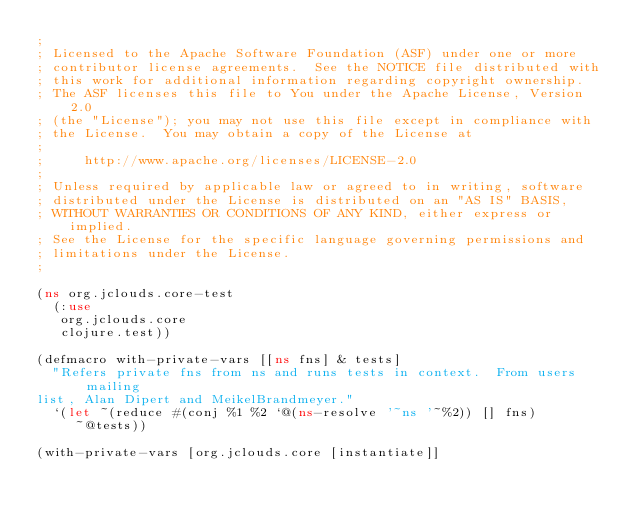<code> <loc_0><loc_0><loc_500><loc_500><_Clojure_>;
; Licensed to the Apache Software Foundation (ASF) under one or more
; contributor license agreements.  See the NOTICE file distributed with
; this work for additional information regarding copyright ownership.
; The ASF licenses this file to You under the Apache License, Version 2.0
; (the "License"); you may not use this file except in compliance with
; the License.  You may obtain a copy of the License at
;
;     http://www.apache.org/licenses/LICENSE-2.0
;
; Unless required by applicable law or agreed to in writing, software
; distributed under the License is distributed on an "AS IS" BASIS,
; WITHOUT WARRANTIES OR CONDITIONS OF ANY KIND, either express or implied.
; See the License for the specific language governing permissions and
; limitations under the License.
;

(ns org.jclouds.core-test
  (:use
   org.jclouds.core
   clojure.test))

(defmacro with-private-vars [[ns fns] & tests]
  "Refers private fns from ns and runs tests in context.  From users mailing
list, Alan Dipert and MeikelBrandmeyer."
  `(let ~(reduce #(conj %1 %2 `@(ns-resolve '~ns '~%2)) [] fns)
     ~@tests))

(with-private-vars [org.jclouds.core [instantiate]]</code> 